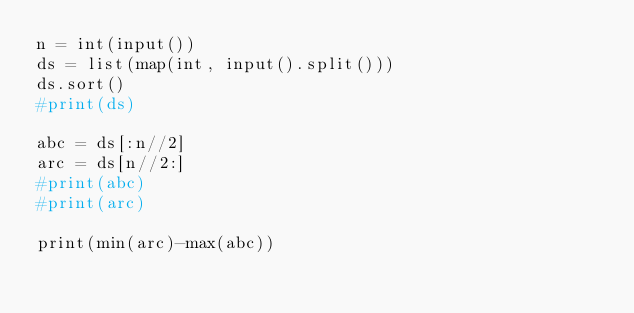<code> <loc_0><loc_0><loc_500><loc_500><_Python_>n = int(input())
ds = list(map(int, input().split()))
ds.sort()
#print(ds)

abc = ds[:n//2]
arc = ds[n//2:]
#print(abc)
#print(arc)

print(min(arc)-max(abc))</code> 